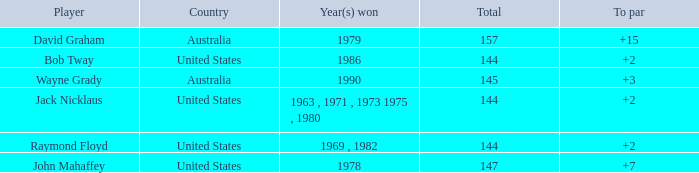What was the average round score of the player who won in 1978? 147.0. 